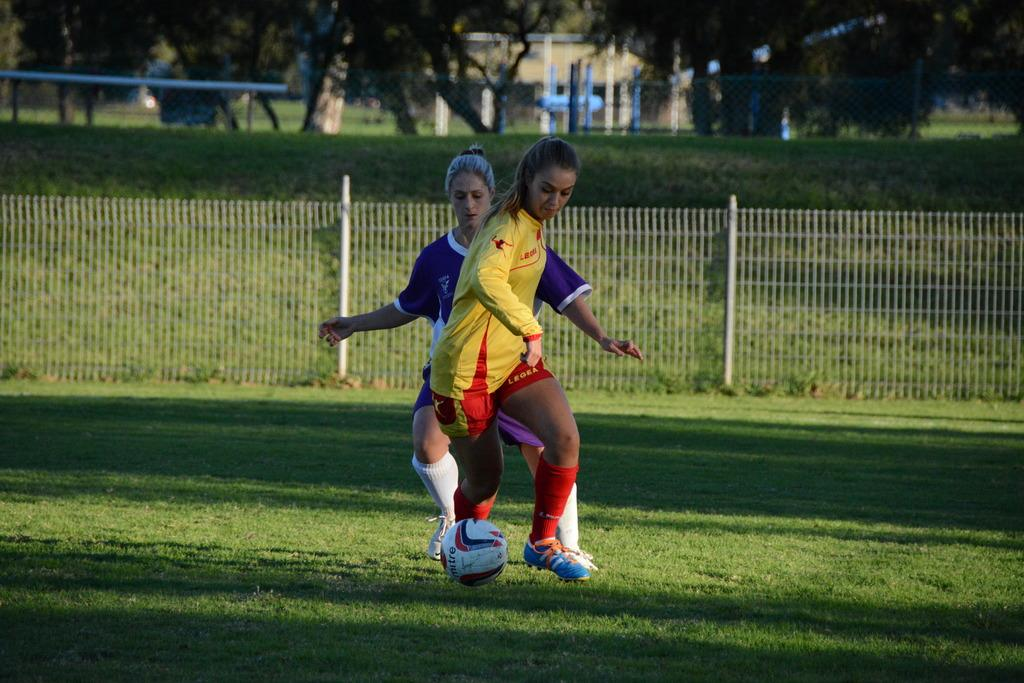How many people are playing football in the image? There are two women playing football in the image. What is the setting of the football game? The football game is taking place on the ground. What is visible in the background of the image? There is a fence visible in the image. What type of bag is being used to carry the football in the image? There is no bag present in the image, and the football is not being carried. 